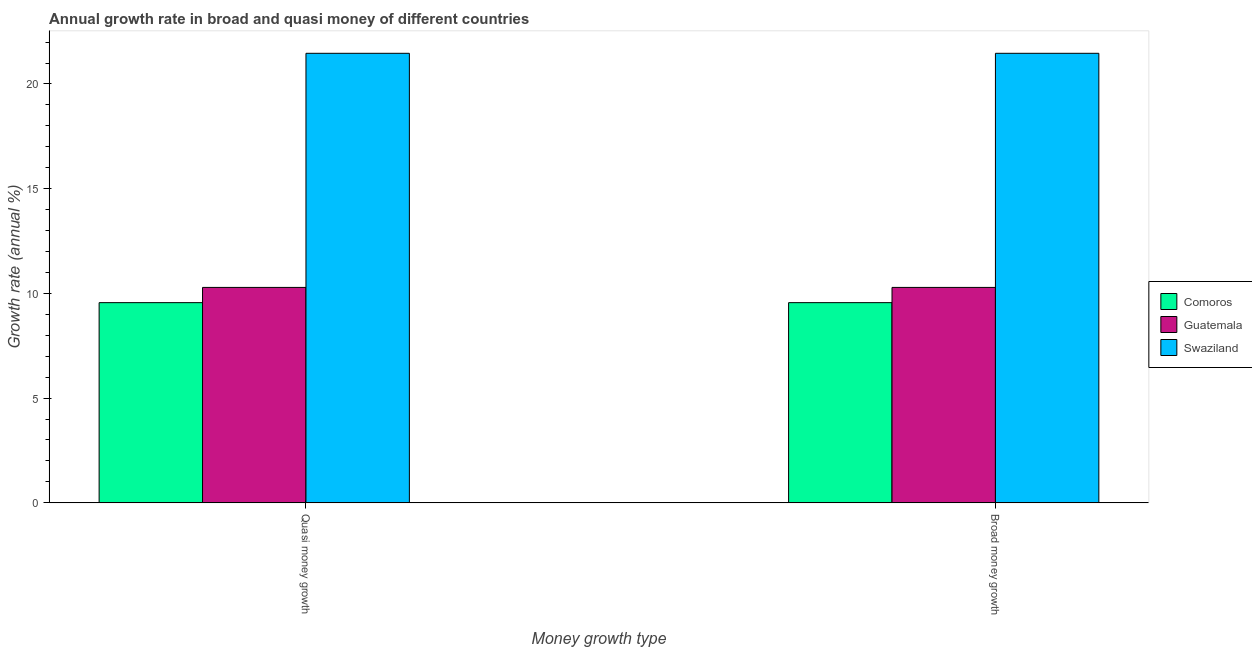How many different coloured bars are there?
Your answer should be very brief. 3. How many groups of bars are there?
Make the answer very short. 2. Are the number of bars per tick equal to the number of legend labels?
Your answer should be very brief. Yes. What is the label of the 1st group of bars from the left?
Ensure brevity in your answer.  Quasi money growth. What is the annual growth rate in broad money in Comoros?
Your answer should be very brief. 9.56. Across all countries, what is the maximum annual growth rate in broad money?
Your response must be concise. 21.47. Across all countries, what is the minimum annual growth rate in broad money?
Offer a very short reply. 9.56. In which country was the annual growth rate in broad money maximum?
Offer a terse response. Swaziland. In which country was the annual growth rate in quasi money minimum?
Provide a short and direct response. Comoros. What is the total annual growth rate in quasi money in the graph?
Your response must be concise. 41.31. What is the difference between the annual growth rate in broad money in Guatemala and that in Comoros?
Make the answer very short. 0.73. What is the difference between the annual growth rate in broad money in Comoros and the annual growth rate in quasi money in Guatemala?
Your answer should be compact. -0.73. What is the average annual growth rate in broad money per country?
Provide a succinct answer. 13.77. What is the ratio of the annual growth rate in quasi money in Guatemala to that in Comoros?
Provide a short and direct response. 1.08. What does the 3rd bar from the left in Broad money growth represents?
Ensure brevity in your answer.  Swaziland. What does the 3rd bar from the right in Quasi money growth represents?
Give a very brief answer. Comoros. How many bars are there?
Offer a terse response. 6. How many countries are there in the graph?
Provide a succinct answer. 3. Does the graph contain grids?
Keep it short and to the point. No. How are the legend labels stacked?
Offer a terse response. Vertical. What is the title of the graph?
Give a very brief answer. Annual growth rate in broad and quasi money of different countries. What is the label or title of the X-axis?
Provide a succinct answer. Money growth type. What is the label or title of the Y-axis?
Your response must be concise. Growth rate (annual %). What is the Growth rate (annual %) in Comoros in Quasi money growth?
Give a very brief answer. 9.56. What is the Growth rate (annual %) in Guatemala in Quasi money growth?
Ensure brevity in your answer.  10.29. What is the Growth rate (annual %) in Swaziland in Quasi money growth?
Offer a very short reply. 21.47. What is the Growth rate (annual %) in Comoros in Broad money growth?
Ensure brevity in your answer.  9.56. What is the Growth rate (annual %) of Guatemala in Broad money growth?
Offer a very short reply. 10.29. What is the Growth rate (annual %) in Swaziland in Broad money growth?
Provide a short and direct response. 21.47. Across all Money growth type, what is the maximum Growth rate (annual %) in Comoros?
Keep it short and to the point. 9.56. Across all Money growth type, what is the maximum Growth rate (annual %) in Guatemala?
Make the answer very short. 10.29. Across all Money growth type, what is the maximum Growth rate (annual %) of Swaziland?
Provide a short and direct response. 21.47. Across all Money growth type, what is the minimum Growth rate (annual %) in Comoros?
Offer a very short reply. 9.56. Across all Money growth type, what is the minimum Growth rate (annual %) of Guatemala?
Keep it short and to the point. 10.29. Across all Money growth type, what is the minimum Growth rate (annual %) in Swaziland?
Provide a succinct answer. 21.47. What is the total Growth rate (annual %) of Comoros in the graph?
Ensure brevity in your answer.  19.12. What is the total Growth rate (annual %) of Guatemala in the graph?
Ensure brevity in your answer.  20.57. What is the total Growth rate (annual %) of Swaziland in the graph?
Ensure brevity in your answer.  42.93. What is the difference between the Growth rate (annual %) in Guatemala in Quasi money growth and that in Broad money growth?
Ensure brevity in your answer.  0. What is the difference between the Growth rate (annual %) in Swaziland in Quasi money growth and that in Broad money growth?
Your response must be concise. 0. What is the difference between the Growth rate (annual %) in Comoros in Quasi money growth and the Growth rate (annual %) in Guatemala in Broad money growth?
Your answer should be very brief. -0.73. What is the difference between the Growth rate (annual %) of Comoros in Quasi money growth and the Growth rate (annual %) of Swaziland in Broad money growth?
Give a very brief answer. -11.91. What is the difference between the Growth rate (annual %) of Guatemala in Quasi money growth and the Growth rate (annual %) of Swaziland in Broad money growth?
Provide a succinct answer. -11.18. What is the average Growth rate (annual %) in Comoros per Money growth type?
Make the answer very short. 9.56. What is the average Growth rate (annual %) of Guatemala per Money growth type?
Ensure brevity in your answer.  10.29. What is the average Growth rate (annual %) in Swaziland per Money growth type?
Your answer should be compact. 21.47. What is the difference between the Growth rate (annual %) in Comoros and Growth rate (annual %) in Guatemala in Quasi money growth?
Your response must be concise. -0.73. What is the difference between the Growth rate (annual %) of Comoros and Growth rate (annual %) of Swaziland in Quasi money growth?
Ensure brevity in your answer.  -11.91. What is the difference between the Growth rate (annual %) in Guatemala and Growth rate (annual %) in Swaziland in Quasi money growth?
Your answer should be compact. -11.18. What is the difference between the Growth rate (annual %) of Comoros and Growth rate (annual %) of Guatemala in Broad money growth?
Your answer should be very brief. -0.73. What is the difference between the Growth rate (annual %) of Comoros and Growth rate (annual %) of Swaziland in Broad money growth?
Your response must be concise. -11.91. What is the difference between the Growth rate (annual %) in Guatemala and Growth rate (annual %) in Swaziland in Broad money growth?
Offer a very short reply. -11.18. What is the ratio of the Growth rate (annual %) of Swaziland in Quasi money growth to that in Broad money growth?
Give a very brief answer. 1. What is the difference between the highest and the lowest Growth rate (annual %) of Comoros?
Provide a short and direct response. 0. What is the difference between the highest and the lowest Growth rate (annual %) of Guatemala?
Offer a terse response. 0. What is the difference between the highest and the lowest Growth rate (annual %) in Swaziland?
Offer a very short reply. 0. 